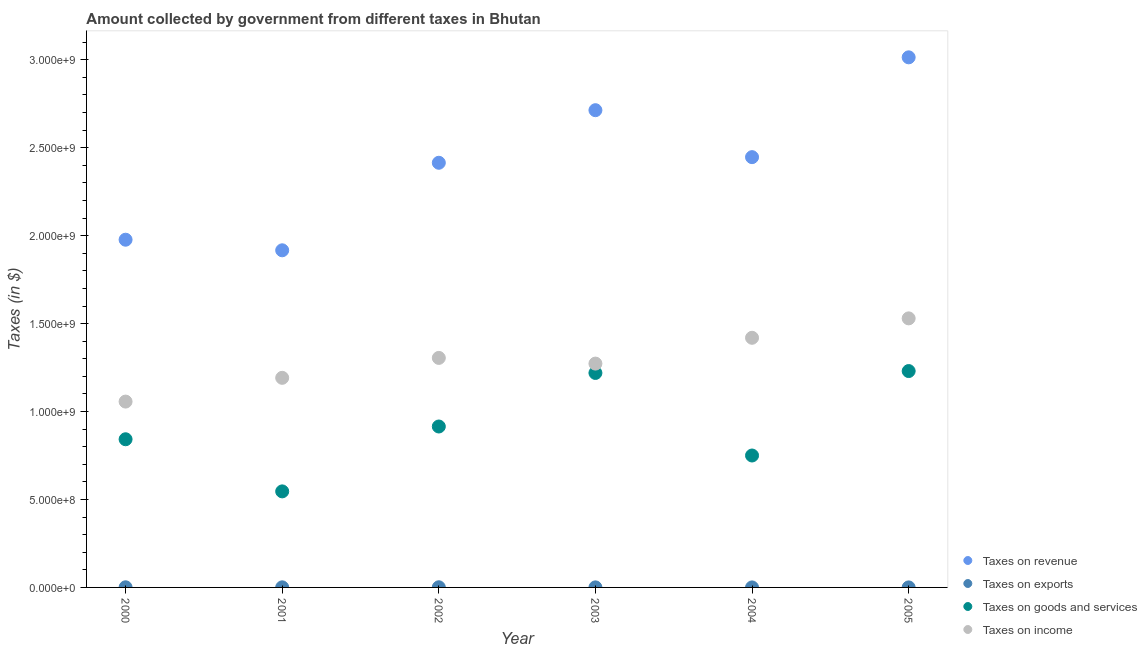Is the number of dotlines equal to the number of legend labels?
Give a very brief answer. Yes. What is the amount collected as tax on income in 2002?
Provide a short and direct response. 1.31e+09. Across all years, what is the maximum amount collected as tax on revenue?
Provide a succinct answer. 3.01e+09. Across all years, what is the minimum amount collected as tax on exports?
Offer a very short reply. 1.20e+04. In which year was the amount collected as tax on exports maximum?
Keep it short and to the point. 2002. What is the total amount collected as tax on income in the graph?
Ensure brevity in your answer.  7.78e+09. What is the difference between the amount collected as tax on exports in 2003 and that in 2005?
Your answer should be very brief. 2.35e+05. What is the difference between the amount collected as tax on exports in 2000 and the amount collected as tax on goods in 2004?
Provide a short and direct response. -7.49e+08. What is the average amount collected as tax on goods per year?
Your response must be concise. 9.17e+08. In the year 2000, what is the difference between the amount collected as tax on exports and amount collected as tax on goods?
Your answer should be compact. -8.42e+08. What is the ratio of the amount collected as tax on exports in 2001 to that in 2002?
Provide a succinct answer. 0.56. Is the difference between the amount collected as tax on revenue in 2001 and 2004 greater than the difference between the amount collected as tax on exports in 2001 and 2004?
Provide a short and direct response. No. What is the difference between the highest and the second highest amount collected as tax on revenue?
Offer a terse response. 3.01e+08. What is the difference between the highest and the lowest amount collected as tax on revenue?
Offer a terse response. 1.10e+09. Does the amount collected as tax on income monotonically increase over the years?
Your response must be concise. No. Is the amount collected as tax on revenue strictly greater than the amount collected as tax on goods over the years?
Keep it short and to the point. Yes. How many dotlines are there?
Give a very brief answer. 4. What is the difference between two consecutive major ticks on the Y-axis?
Provide a short and direct response. 5.00e+08. How many legend labels are there?
Give a very brief answer. 4. How are the legend labels stacked?
Offer a terse response. Vertical. What is the title of the graph?
Your answer should be very brief. Amount collected by government from different taxes in Bhutan. Does "International Development Association" appear as one of the legend labels in the graph?
Your answer should be compact. No. What is the label or title of the X-axis?
Your answer should be very brief. Year. What is the label or title of the Y-axis?
Ensure brevity in your answer.  Taxes (in $). What is the Taxes (in $) of Taxes on revenue in 2000?
Provide a succinct answer. 1.98e+09. What is the Taxes (in $) of Taxes on exports in 2000?
Offer a very short reply. 7.63e+05. What is the Taxes (in $) in Taxes on goods and services in 2000?
Your response must be concise. 8.42e+08. What is the Taxes (in $) in Taxes on income in 2000?
Make the answer very short. 1.06e+09. What is the Taxes (in $) in Taxes on revenue in 2001?
Your answer should be very brief. 1.92e+09. What is the Taxes (in $) of Taxes on exports in 2001?
Offer a very short reply. 4.91e+05. What is the Taxes (in $) in Taxes on goods and services in 2001?
Offer a terse response. 5.46e+08. What is the Taxes (in $) in Taxes on income in 2001?
Make the answer very short. 1.19e+09. What is the Taxes (in $) in Taxes on revenue in 2002?
Your answer should be very brief. 2.41e+09. What is the Taxes (in $) of Taxes on exports in 2002?
Offer a terse response. 8.70e+05. What is the Taxes (in $) of Taxes on goods and services in 2002?
Provide a succinct answer. 9.15e+08. What is the Taxes (in $) of Taxes on income in 2002?
Ensure brevity in your answer.  1.31e+09. What is the Taxes (in $) of Taxes on revenue in 2003?
Give a very brief answer. 2.71e+09. What is the Taxes (in $) in Taxes on exports in 2003?
Ensure brevity in your answer.  3.39e+05. What is the Taxes (in $) in Taxes on goods and services in 2003?
Offer a terse response. 1.22e+09. What is the Taxes (in $) in Taxes on income in 2003?
Your answer should be very brief. 1.27e+09. What is the Taxes (in $) in Taxes on revenue in 2004?
Keep it short and to the point. 2.45e+09. What is the Taxes (in $) in Taxes on exports in 2004?
Your response must be concise. 1.20e+04. What is the Taxes (in $) of Taxes on goods and services in 2004?
Give a very brief answer. 7.50e+08. What is the Taxes (in $) of Taxes on income in 2004?
Make the answer very short. 1.42e+09. What is the Taxes (in $) in Taxes on revenue in 2005?
Keep it short and to the point. 3.01e+09. What is the Taxes (in $) in Taxes on exports in 2005?
Ensure brevity in your answer.  1.04e+05. What is the Taxes (in $) of Taxes on goods and services in 2005?
Provide a short and direct response. 1.23e+09. What is the Taxes (in $) of Taxes on income in 2005?
Provide a short and direct response. 1.53e+09. Across all years, what is the maximum Taxes (in $) of Taxes on revenue?
Offer a terse response. 3.01e+09. Across all years, what is the maximum Taxes (in $) of Taxes on exports?
Provide a short and direct response. 8.70e+05. Across all years, what is the maximum Taxes (in $) in Taxes on goods and services?
Keep it short and to the point. 1.23e+09. Across all years, what is the maximum Taxes (in $) in Taxes on income?
Offer a very short reply. 1.53e+09. Across all years, what is the minimum Taxes (in $) of Taxes on revenue?
Make the answer very short. 1.92e+09. Across all years, what is the minimum Taxes (in $) of Taxes on exports?
Offer a terse response. 1.20e+04. Across all years, what is the minimum Taxes (in $) of Taxes on goods and services?
Provide a short and direct response. 5.46e+08. Across all years, what is the minimum Taxes (in $) in Taxes on income?
Provide a succinct answer. 1.06e+09. What is the total Taxes (in $) in Taxes on revenue in the graph?
Offer a very short reply. 1.45e+1. What is the total Taxes (in $) in Taxes on exports in the graph?
Your answer should be compact. 2.58e+06. What is the total Taxes (in $) of Taxes on goods and services in the graph?
Offer a terse response. 5.50e+09. What is the total Taxes (in $) of Taxes on income in the graph?
Ensure brevity in your answer.  7.78e+09. What is the difference between the Taxes (in $) in Taxes on revenue in 2000 and that in 2001?
Give a very brief answer. 6.02e+07. What is the difference between the Taxes (in $) in Taxes on exports in 2000 and that in 2001?
Your answer should be compact. 2.72e+05. What is the difference between the Taxes (in $) of Taxes on goods and services in 2000 and that in 2001?
Your answer should be compact. 2.96e+08. What is the difference between the Taxes (in $) in Taxes on income in 2000 and that in 2001?
Keep it short and to the point. -1.35e+08. What is the difference between the Taxes (in $) in Taxes on revenue in 2000 and that in 2002?
Give a very brief answer. -4.37e+08. What is the difference between the Taxes (in $) of Taxes on exports in 2000 and that in 2002?
Provide a short and direct response. -1.07e+05. What is the difference between the Taxes (in $) in Taxes on goods and services in 2000 and that in 2002?
Keep it short and to the point. -7.25e+07. What is the difference between the Taxes (in $) in Taxes on income in 2000 and that in 2002?
Your answer should be very brief. -2.48e+08. What is the difference between the Taxes (in $) of Taxes on revenue in 2000 and that in 2003?
Your answer should be very brief. -7.36e+08. What is the difference between the Taxes (in $) in Taxes on exports in 2000 and that in 2003?
Offer a very short reply. 4.24e+05. What is the difference between the Taxes (in $) in Taxes on goods and services in 2000 and that in 2003?
Keep it short and to the point. -3.77e+08. What is the difference between the Taxes (in $) in Taxes on income in 2000 and that in 2003?
Ensure brevity in your answer.  -2.16e+08. What is the difference between the Taxes (in $) in Taxes on revenue in 2000 and that in 2004?
Offer a terse response. -4.69e+08. What is the difference between the Taxes (in $) of Taxes on exports in 2000 and that in 2004?
Offer a terse response. 7.51e+05. What is the difference between the Taxes (in $) in Taxes on goods and services in 2000 and that in 2004?
Provide a short and direct response. 9.24e+07. What is the difference between the Taxes (in $) of Taxes on income in 2000 and that in 2004?
Offer a terse response. -3.63e+08. What is the difference between the Taxes (in $) in Taxes on revenue in 2000 and that in 2005?
Offer a terse response. -1.04e+09. What is the difference between the Taxes (in $) of Taxes on exports in 2000 and that in 2005?
Offer a terse response. 6.59e+05. What is the difference between the Taxes (in $) of Taxes on goods and services in 2000 and that in 2005?
Give a very brief answer. -3.88e+08. What is the difference between the Taxes (in $) in Taxes on income in 2000 and that in 2005?
Ensure brevity in your answer.  -4.73e+08. What is the difference between the Taxes (in $) in Taxes on revenue in 2001 and that in 2002?
Ensure brevity in your answer.  -4.98e+08. What is the difference between the Taxes (in $) in Taxes on exports in 2001 and that in 2002?
Keep it short and to the point. -3.79e+05. What is the difference between the Taxes (in $) in Taxes on goods and services in 2001 and that in 2002?
Provide a succinct answer. -3.69e+08. What is the difference between the Taxes (in $) of Taxes on income in 2001 and that in 2002?
Ensure brevity in your answer.  -1.13e+08. What is the difference between the Taxes (in $) in Taxes on revenue in 2001 and that in 2003?
Make the answer very short. -7.97e+08. What is the difference between the Taxes (in $) of Taxes on exports in 2001 and that in 2003?
Provide a succinct answer. 1.52e+05. What is the difference between the Taxes (in $) in Taxes on goods and services in 2001 and that in 2003?
Keep it short and to the point. -6.73e+08. What is the difference between the Taxes (in $) in Taxes on income in 2001 and that in 2003?
Keep it short and to the point. -8.09e+07. What is the difference between the Taxes (in $) in Taxes on revenue in 2001 and that in 2004?
Provide a succinct answer. -5.30e+08. What is the difference between the Taxes (in $) of Taxes on exports in 2001 and that in 2004?
Your answer should be compact. 4.79e+05. What is the difference between the Taxes (in $) in Taxes on goods and services in 2001 and that in 2004?
Offer a terse response. -2.04e+08. What is the difference between the Taxes (in $) in Taxes on income in 2001 and that in 2004?
Provide a succinct answer. -2.28e+08. What is the difference between the Taxes (in $) in Taxes on revenue in 2001 and that in 2005?
Give a very brief answer. -1.10e+09. What is the difference between the Taxes (in $) of Taxes on exports in 2001 and that in 2005?
Ensure brevity in your answer.  3.87e+05. What is the difference between the Taxes (in $) in Taxes on goods and services in 2001 and that in 2005?
Provide a succinct answer. -6.84e+08. What is the difference between the Taxes (in $) of Taxes on income in 2001 and that in 2005?
Offer a very short reply. -3.38e+08. What is the difference between the Taxes (in $) of Taxes on revenue in 2002 and that in 2003?
Give a very brief answer. -2.99e+08. What is the difference between the Taxes (in $) of Taxes on exports in 2002 and that in 2003?
Offer a very short reply. 5.31e+05. What is the difference between the Taxes (in $) in Taxes on goods and services in 2002 and that in 2003?
Your response must be concise. -3.04e+08. What is the difference between the Taxes (in $) in Taxes on income in 2002 and that in 2003?
Your response must be concise. 3.24e+07. What is the difference between the Taxes (in $) in Taxes on revenue in 2002 and that in 2004?
Give a very brief answer. -3.20e+07. What is the difference between the Taxes (in $) in Taxes on exports in 2002 and that in 2004?
Provide a succinct answer. 8.58e+05. What is the difference between the Taxes (in $) in Taxes on goods and services in 2002 and that in 2004?
Your response must be concise. 1.65e+08. What is the difference between the Taxes (in $) of Taxes on income in 2002 and that in 2004?
Give a very brief answer. -1.14e+08. What is the difference between the Taxes (in $) in Taxes on revenue in 2002 and that in 2005?
Ensure brevity in your answer.  -6.00e+08. What is the difference between the Taxes (in $) of Taxes on exports in 2002 and that in 2005?
Ensure brevity in your answer.  7.66e+05. What is the difference between the Taxes (in $) in Taxes on goods and services in 2002 and that in 2005?
Your response must be concise. -3.15e+08. What is the difference between the Taxes (in $) of Taxes on income in 2002 and that in 2005?
Your answer should be very brief. -2.25e+08. What is the difference between the Taxes (in $) in Taxes on revenue in 2003 and that in 2004?
Your response must be concise. 2.67e+08. What is the difference between the Taxes (in $) in Taxes on exports in 2003 and that in 2004?
Give a very brief answer. 3.27e+05. What is the difference between the Taxes (in $) of Taxes on goods and services in 2003 and that in 2004?
Offer a terse response. 4.69e+08. What is the difference between the Taxes (in $) in Taxes on income in 2003 and that in 2004?
Offer a very short reply. -1.47e+08. What is the difference between the Taxes (in $) in Taxes on revenue in 2003 and that in 2005?
Provide a succinct answer. -3.01e+08. What is the difference between the Taxes (in $) of Taxes on exports in 2003 and that in 2005?
Ensure brevity in your answer.  2.35e+05. What is the difference between the Taxes (in $) of Taxes on goods and services in 2003 and that in 2005?
Your response must be concise. -1.08e+07. What is the difference between the Taxes (in $) of Taxes on income in 2003 and that in 2005?
Offer a terse response. -2.57e+08. What is the difference between the Taxes (in $) in Taxes on revenue in 2004 and that in 2005?
Offer a very short reply. -5.68e+08. What is the difference between the Taxes (in $) of Taxes on exports in 2004 and that in 2005?
Ensure brevity in your answer.  -9.20e+04. What is the difference between the Taxes (in $) in Taxes on goods and services in 2004 and that in 2005?
Your answer should be compact. -4.80e+08. What is the difference between the Taxes (in $) in Taxes on income in 2004 and that in 2005?
Your answer should be very brief. -1.10e+08. What is the difference between the Taxes (in $) in Taxes on revenue in 2000 and the Taxes (in $) in Taxes on exports in 2001?
Provide a short and direct response. 1.98e+09. What is the difference between the Taxes (in $) of Taxes on revenue in 2000 and the Taxes (in $) of Taxes on goods and services in 2001?
Your response must be concise. 1.43e+09. What is the difference between the Taxes (in $) in Taxes on revenue in 2000 and the Taxes (in $) in Taxes on income in 2001?
Ensure brevity in your answer.  7.85e+08. What is the difference between the Taxes (in $) in Taxes on exports in 2000 and the Taxes (in $) in Taxes on goods and services in 2001?
Make the answer very short. -5.45e+08. What is the difference between the Taxes (in $) in Taxes on exports in 2000 and the Taxes (in $) in Taxes on income in 2001?
Ensure brevity in your answer.  -1.19e+09. What is the difference between the Taxes (in $) in Taxes on goods and services in 2000 and the Taxes (in $) in Taxes on income in 2001?
Offer a very short reply. -3.49e+08. What is the difference between the Taxes (in $) of Taxes on revenue in 2000 and the Taxes (in $) of Taxes on exports in 2002?
Keep it short and to the point. 1.98e+09. What is the difference between the Taxes (in $) in Taxes on revenue in 2000 and the Taxes (in $) in Taxes on goods and services in 2002?
Offer a terse response. 1.06e+09. What is the difference between the Taxes (in $) of Taxes on revenue in 2000 and the Taxes (in $) of Taxes on income in 2002?
Offer a very short reply. 6.72e+08. What is the difference between the Taxes (in $) of Taxes on exports in 2000 and the Taxes (in $) of Taxes on goods and services in 2002?
Offer a very short reply. -9.14e+08. What is the difference between the Taxes (in $) in Taxes on exports in 2000 and the Taxes (in $) in Taxes on income in 2002?
Give a very brief answer. -1.30e+09. What is the difference between the Taxes (in $) of Taxes on goods and services in 2000 and the Taxes (in $) of Taxes on income in 2002?
Your answer should be very brief. -4.63e+08. What is the difference between the Taxes (in $) in Taxes on revenue in 2000 and the Taxes (in $) in Taxes on exports in 2003?
Provide a short and direct response. 1.98e+09. What is the difference between the Taxes (in $) of Taxes on revenue in 2000 and the Taxes (in $) of Taxes on goods and services in 2003?
Your answer should be very brief. 7.58e+08. What is the difference between the Taxes (in $) of Taxes on revenue in 2000 and the Taxes (in $) of Taxes on income in 2003?
Give a very brief answer. 7.04e+08. What is the difference between the Taxes (in $) in Taxes on exports in 2000 and the Taxes (in $) in Taxes on goods and services in 2003?
Your answer should be very brief. -1.22e+09. What is the difference between the Taxes (in $) of Taxes on exports in 2000 and the Taxes (in $) of Taxes on income in 2003?
Offer a very short reply. -1.27e+09. What is the difference between the Taxes (in $) of Taxes on goods and services in 2000 and the Taxes (in $) of Taxes on income in 2003?
Your answer should be very brief. -4.30e+08. What is the difference between the Taxes (in $) of Taxes on revenue in 2000 and the Taxes (in $) of Taxes on exports in 2004?
Give a very brief answer. 1.98e+09. What is the difference between the Taxes (in $) of Taxes on revenue in 2000 and the Taxes (in $) of Taxes on goods and services in 2004?
Your answer should be compact. 1.23e+09. What is the difference between the Taxes (in $) in Taxes on revenue in 2000 and the Taxes (in $) in Taxes on income in 2004?
Provide a short and direct response. 5.58e+08. What is the difference between the Taxes (in $) in Taxes on exports in 2000 and the Taxes (in $) in Taxes on goods and services in 2004?
Give a very brief answer. -7.49e+08. What is the difference between the Taxes (in $) of Taxes on exports in 2000 and the Taxes (in $) of Taxes on income in 2004?
Make the answer very short. -1.42e+09. What is the difference between the Taxes (in $) in Taxes on goods and services in 2000 and the Taxes (in $) in Taxes on income in 2004?
Your response must be concise. -5.77e+08. What is the difference between the Taxes (in $) in Taxes on revenue in 2000 and the Taxes (in $) in Taxes on exports in 2005?
Provide a short and direct response. 1.98e+09. What is the difference between the Taxes (in $) of Taxes on revenue in 2000 and the Taxes (in $) of Taxes on goods and services in 2005?
Provide a short and direct response. 7.47e+08. What is the difference between the Taxes (in $) in Taxes on revenue in 2000 and the Taxes (in $) in Taxes on income in 2005?
Provide a succinct answer. 4.47e+08. What is the difference between the Taxes (in $) of Taxes on exports in 2000 and the Taxes (in $) of Taxes on goods and services in 2005?
Provide a short and direct response. -1.23e+09. What is the difference between the Taxes (in $) of Taxes on exports in 2000 and the Taxes (in $) of Taxes on income in 2005?
Offer a very short reply. -1.53e+09. What is the difference between the Taxes (in $) in Taxes on goods and services in 2000 and the Taxes (in $) in Taxes on income in 2005?
Your answer should be compact. -6.87e+08. What is the difference between the Taxes (in $) in Taxes on revenue in 2001 and the Taxes (in $) in Taxes on exports in 2002?
Your answer should be compact. 1.92e+09. What is the difference between the Taxes (in $) in Taxes on revenue in 2001 and the Taxes (in $) in Taxes on goods and services in 2002?
Give a very brief answer. 1.00e+09. What is the difference between the Taxes (in $) of Taxes on revenue in 2001 and the Taxes (in $) of Taxes on income in 2002?
Provide a short and direct response. 6.12e+08. What is the difference between the Taxes (in $) in Taxes on exports in 2001 and the Taxes (in $) in Taxes on goods and services in 2002?
Offer a terse response. -9.15e+08. What is the difference between the Taxes (in $) in Taxes on exports in 2001 and the Taxes (in $) in Taxes on income in 2002?
Ensure brevity in your answer.  -1.30e+09. What is the difference between the Taxes (in $) in Taxes on goods and services in 2001 and the Taxes (in $) in Taxes on income in 2002?
Your response must be concise. -7.59e+08. What is the difference between the Taxes (in $) in Taxes on revenue in 2001 and the Taxes (in $) in Taxes on exports in 2003?
Your answer should be compact. 1.92e+09. What is the difference between the Taxes (in $) in Taxes on revenue in 2001 and the Taxes (in $) in Taxes on goods and services in 2003?
Offer a terse response. 6.97e+08. What is the difference between the Taxes (in $) in Taxes on revenue in 2001 and the Taxes (in $) in Taxes on income in 2003?
Give a very brief answer. 6.44e+08. What is the difference between the Taxes (in $) of Taxes on exports in 2001 and the Taxes (in $) of Taxes on goods and services in 2003?
Make the answer very short. -1.22e+09. What is the difference between the Taxes (in $) in Taxes on exports in 2001 and the Taxes (in $) in Taxes on income in 2003?
Provide a succinct answer. -1.27e+09. What is the difference between the Taxes (in $) of Taxes on goods and services in 2001 and the Taxes (in $) of Taxes on income in 2003?
Make the answer very short. -7.27e+08. What is the difference between the Taxes (in $) in Taxes on revenue in 2001 and the Taxes (in $) in Taxes on exports in 2004?
Your answer should be very brief. 1.92e+09. What is the difference between the Taxes (in $) of Taxes on revenue in 2001 and the Taxes (in $) of Taxes on goods and services in 2004?
Ensure brevity in your answer.  1.17e+09. What is the difference between the Taxes (in $) of Taxes on revenue in 2001 and the Taxes (in $) of Taxes on income in 2004?
Offer a terse response. 4.97e+08. What is the difference between the Taxes (in $) of Taxes on exports in 2001 and the Taxes (in $) of Taxes on goods and services in 2004?
Keep it short and to the point. -7.50e+08. What is the difference between the Taxes (in $) of Taxes on exports in 2001 and the Taxes (in $) of Taxes on income in 2004?
Your answer should be compact. -1.42e+09. What is the difference between the Taxes (in $) of Taxes on goods and services in 2001 and the Taxes (in $) of Taxes on income in 2004?
Ensure brevity in your answer.  -8.73e+08. What is the difference between the Taxes (in $) in Taxes on revenue in 2001 and the Taxes (in $) in Taxes on exports in 2005?
Provide a short and direct response. 1.92e+09. What is the difference between the Taxes (in $) in Taxes on revenue in 2001 and the Taxes (in $) in Taxes on goods and services in 2005?
Provide a short and direct response. 6.87e+08. What is the difference between the Taxes (in $) in Taxes on revenue in 2001 and the Taxes (in $) in Taxes on income in 2005?
Your answer should be compact. 3.87e+08. What is the difference between the Taxes (in $) of Taxes on exports in 2001 and the Taxes (in $) of Taxes on goods and services in 2005?
Your answer should be compact. -1.23e+09. What is the difference between the Taxes (in $) in Taxes on exports in 2001 and the Taxes (in $) in Taxes on income in 2005?
Provide a short and direct response. -1.53e+09. What is the difference between the Taxes (in $) in Taxes on goods and services in 2001 and the Taxes (in $) in Taxes on income in 2005?
Keep it short and to the point. -9.84e+08. What is the difference between the Taxes (in $) in Taxes on revenue in 2002 and the Taxes (in $) in Taxes on exports in 2003?
Your answer should be very brief. 2.41e+09. What is the difference between the Taxes (in $) in Taxes on revenue in 2002 and the Taxes (in $) in Taxes on goods and services in 2003?
Keep it short and to the point. 1.20e+09. What is the difference between the Taxes (in $) in Taxes on revenue in 2002 and the Taxes (in $) in Taxes on income in 2003?
Give a very brief answer. 1.14e+09. What is the difference between the Taxes (in $) of Taxes on exports in 2002 and the Taxes (in $) of Taxes on goods and services in 2003?
Keep it short and to the point. -1.22e+09. What is the difference between the Taxes (in $) in Taxes on exports in 2002 and the Taxes (in $) in Taxes on income in 2003?
Provide a short and direct response. -1.27e+09. What is the difference between the Taxes (in $) in Taxes on goods and services in 2002 and the Taxes (in $) in Taxes on income in 2003?
Ensure brevity in your answer.  -3.58e+08. What is the difference between the Taxes (in $) in Taxes on revenue in 2002 and the Taxes (in $) in Taxes on exports in 2004?
Offer a terse response. 2.41e+09. What is the difference between the Taxes (in $) of Taxes on revenue in 2002 and the Taxes (in $) of Taxes on goods and services in 2004?
Your answer should be very brief. 1.66e+09. What is the difference between the Taxes (in $) in Taxes on revenue in 2002 and the Taxes (in $) in Taxes on income in 2004?
Your response must be concise. 9.95e+08. What is the difference between the Taxes (in $) in Taxes on exports in 2002 and the Taxes (in $) in Taxes on goods and services in 2004?
Keep it short and to the point. -7.49e+08. What is the difference between the Taxes (in $) of Taxes on exports in 2002 and the Taxes (in $) of Taxes on income in 2004?
Your answer should be very brief. -1.42e+09. What is the difference between the Taxes (in $) in Taxes on goods and services in 2002 and the Taxes (in $) in Taxes on income in 2004?
Offer a very short reply. -5.04e+08. What is the difference between the Taxes (in $) in Taxes on revenue in 2002 and the Taxes (in $) in Taxes on exports in 2005?
Make the answer very short. 2.41e+09. What is the difference between the Taxes (in $) of Taxes on revenue in 2002 and the Taxes (in $) of Taxes on goods and services in 2005?
Your response must be concise. 1.18e+09. What is the difference between the Taxes (in $) of Taxes on revenue in 2002 and the Taxes (in $) of Taxes on income in 2005?
Give a very brief answer. 8.85e+08. What is the difference between the Taxes (in $) in Taxes on exports in 2002 and the Taxes (in $) in Taxes on goods and services in 2005?
Keep it short and to the point. -1.23e+09. What is the difference between the Taxes (in $) in Taxes on exports in 2002 and the Taxes (in $) in Taxes on income in 2005?
Give a very brief answer. -1.53e+09. What is the difference between the Taxes (in $) of Taxes on goods and services in 2002 and the Taxes (in $) of Taxes on income in 2005?
Give a very brief answer. -6.15e+08. What is the difference between the Taxes (in $) in Taxes on revenue in 2003 and the Taxes (in $) in Taxes on exports in 2004?
Provide a succinct answer. 2.71e+09. What is the difference between the Taxes (in $) in Taxes on revenue in 2003 and the Taxes (in $) in Taxes on goods and services in 2004?
Keep it short and to the point. 1.96e+09. What is the difference between the Taxes (in $) in Taxes on revenue in 2003 and the Taxes (in $) in Taxes on income in 2004?
Provide a short and direct response. 1.29e+09. What is the difference between the Taxes (in $) in Taxes on exports in 2003 and the Taxes (in $) in Taxes on goods and services in 2004?
Provide a succinct answer. -7.50e+08. What is the difference between the Taxes (in $) in Taxes on exports in 2003 and the Taxes (in $) in Taxes on income in 2004?
Offer a very short reply. -1.42e+09. What is the difference between the Taxes (in $) of Taxes on goods and services in 2003 and the Taxes (in $) of Taxes on income in 2004?
Your answer should be compact. -2.00e+08. What is the difference between the Taxes (in $) in Taxes on revenue in 2003 and the Taxes (in $) in Taxes on exports in 2005?
Offer a very short reply. 2.71e+09. What is the difference between the Taxes (in $) in Taxes on revenue in 2003 and the Taxes (in $) in Taxes on goods and services in 2005?
Offer a very short reply. 1.48e+09. What is the difference between the Taxes (in $) of Taxes on revenue in 2003 and the Taxes (in $) of Taxes on income in 2005?
Ensure brevity in your answer.  1.18e+09. What is the difference between the Taxes (in $) of Taxes on exports in 2003 and the Taxes (in $) of Taxes on goods and services in 2005?
Provide a succinct answer. -1.23e+09. What is the difference between the Taxes (in $) of Taxes on exports in 2003 and the Taxes (in $) of Taxes on income in 2005?
Give a very brief answer. -1.53e+09. What is the difference between the Taxes (in $) of Taxes on goods and services in 2003 and the Taxes (in $) of Taxes on income in 2005?
Your answer should be compact. -3.10e+08. What is the difference between the Taxes (in $) in Taxes on revenue in 2004 and the Taxes (in $) in Taxes on exports in 2005?
Offer a terse response. 2.45e+09. What is the difference between the Taxes (in $) of Taxes on revenue in 2004 and the Taxes (in $) of Taxes on goods and services in 2005?
Give a very brief answer. 1.22e+09. What is the difference between the Taxes (in $) in Taxes on revenue in 2004 and the Taxes (in $) in Taxes on income in 2005?
Your answer should be compact. 9.17e+08. What is the difference between the Taxes (in $) in Taxes on exports in 2004 and the Taxes (in $) in Taxes on goods and services in 2005?
Your answer should be compact. -1.23e+09. What is the difference between the Taxes (in $) in Taxes on exports in 2004 and the Taxes (in $) in Taxes on income in 2005?
Your response must be concise. -1.53e+09. What is the difference between the Taxes (in $) in Taxes on goods and services in 2004 and the Taxes (in $) in Taxes on income in 2005?
Make the answer very short. -7.80e+08. What is the average Taxes (in $) of Taxes on revenue per year?
Provide a short and direct response. 2.41e+09. What is the average Taxes (in $) of Taxes on exports per year?
Provide a succinct answer. 4.30e+05. What is the average Taxes (in $) of Taxes on goods and services per year?
Provide a short and direct response. 9.17e+08. What is the average Taxes (in $) in Taxes on income per year?
Provide a short and direct response. 1.30e+09. In the year 2000, what is the difference between the Taxes (in $) of Taxes on revenue and Taxes (in $) of Taxes on exports?
Your response must be concise. 1.98e+09. In the year 2000, what is the difference between the Taxes (in $) of Taxes on revenue and Taxes (in $) of Taxes on goods and services?
Make the answer very short. 1.13e+09. In the year 2000, what is the difference between the Taxes (in $) of Taxes on revenue and Taxes (in $) of Taxes on income?
Your answer should be compact. 9.20e+08. In the year 2000, what is the difference between the Taxes (in $) in Taxes on exports and Taxes (in $) in Taxes on goods and services?
Provide a succinct answer. -8.42e+08. In the year 2000, what is the difference between the Taxes (in $) of Taxes on exports and Taxes (in $) of Taxes on income?
Your answer should be compact. -1.06e+09. In the year 2000, what is the difference between the Taxes (in $) in Taxes on goods and services and Taxes (in $) in Taxes on income?
Give a very brief answer. -2.14e+08. In the year 2001, what is the difference between the Taxes (in $) in Taxes on revenue and Taxes (in $) in Taxes on exports?
Offer a very short reply. 1.92e+09. In the year 2001, what is the difference between the Taxes (in $) in Taxes on revenue and Taxes (in $) in Taxes on goods and services?
Your answer should be very brief. 1.37e+09. In the year 2001, what is the difference between the Taxes (in $) of Taxes on revenue and Taxes (in $) of Taxes on income?
Give a very brief answer. 7.25e+08. In the year 2001, what is the difference between the Taxes (in $) in Taxes on exports and Taxes (in $) in Taxes on goods and services?
Keep it short and to the point. -5.46e+08. In the year 2001, what is the difference between the Taxes (in $) of Taxes on exports and Taxes (in $) of Taxes on income?
Provide a short and direct response. -1.19e+09. In the year 2001, what is the difference between the Taxes (in $) in Taxes on goods and services and Taxes (in $) in Taxes on income?
Offer a terse response. -6.46e+08. In the year 2002, what is the difference between the Taxes (in $) in Taxes on revenue and Taxes (in $) in Taxes on exports?
Offer a terse response. 2.41e+09. In the year 2002, what is the difference between the Taxes (in $) in Taxes on revenue and Taxes (in $) in Taxes on goods and services?
Give a very brief answer. 1.50e+09. In the year 2002, what is the difference between the Taxes (in $) in Taxes on revenue and Taxes (in $) in Taxes on income?
Offer a very short reply. 1.11e+09. In the year 2002, what is the difference between the Taxes (in $) of Taxes on exports and Taxes (in $) of Taxes on goods and services?
Ensure brevity in your answer.  -9.14e+08. In the year 2002, what is the difference between the Taxes (in $) of Taxes on exports and Taxes (in $) of Taxes on income?
Your response must be concise. -1.30e+09. In the year 2002, what is the difference between the Taxes (in $) of Taxes on goods and services and Taxes (in $) of Taxes on income?
Ensure brevity in your answer.  -3.90e+08. In the year 2003, what is the difference between the Taxes (in $) in Taxes on revenue and Taxes (in $) in Taxes on exports?
Give a very brief answer. 2.71e+09. In the year 2003, what is the difference between the Taxes (in $) in Taxes on revenue and Taxes (in $) in Taxes on goods and services?
Keep it short and to the point. 1.49e+09. In the year 2003, what is the difference between the Taxes (in $) in Taxes on revenue and Taxes (in $) in Taxes on income?
Provide a short and direct response. 1.44e+09. In the year 2003, what is the difference between the Taxes (in $) in Taxes on exports and Taxes (in $) in Taxes on goods and services?
Give a very brief answer. -1.22e+09. In the year 2003, what is the difference between the Taxes (in $) of Taxes on exports and Taxes (in $) of Taxes on income?
Offer a very short reply. -1.27e+09. In the year 2003, what is the difference between the Taxes (in $) in Taxes on goods and services and Taxes (in $) in Taxes on income?
Ensure brevity in your answer.  -5.32e+07. In the year 2004, what is the difference between the Taxes (in $) of Taxes on revenue and Taxes (in $) of Taxes on exports?
Ensure brevity in your answer.  2.45e+09. In the year 2004, what is the difference between the Taxes (in $) of Taxes on revenue and Taxes (in $) of Taxes on goods and services?
Offer a terse response. 1.70e+09. In the year 2004, what is the difference between the Taxes (in $) in Taxes on revenue and Taxes (in $) in Taxes on income?
Your answer should be very brief. 1.03e+09. In the year 2004, what is the difference between the Taxes (in $) in Taxes on exports and Taxes (in $) in Taxes on goods and services?
Give a very brief answer. -7.50e+08. In the year 2004, what is the difference between the Taxes (in $) in Taxes on exports and Taxes (in $) in Taxes on income?
Ensure brevity in your answer.  -1.42e+09. In the year 2004, what is the difference between the Taxes (in $) of Taxes on goods and services and Taxes (in $) of Taxes on income?
Keep it short and to the point. -6.69e+08. In the year 2005, what is the difference between the Taxes (in $) of Taxes on revenue and Taxes (in $) of Taxes on exports?
Make the answer very short. 3.01e+09. In the year 2005, what is the difference between the Taxes (in $) in Taxes on revenue and Taxes (in $) in Taxes on goods and services?
Make the answer very short. 1.78e+09. In the year 2005, what is the difference between the Taxes (in $) in Taxes on revenue and Taxes (in $) in Taxes on income?
Ensure brevity in your answer.  1.48e+09. In the year 2005, what is the difference between the Taxes (in $) of Taxes on exports and Taxes (in $) of Taxes on goods and services?
Offer a very short reply. -1.23e+09. In the year 2005, what is the difference between the Taxes (in $) in Taxes on exports and Taxes (in $) in Taxes on income?
Make the answer very short. -1.53e+09. In the year 2005, what is the difference between the Taxes (in $) of Taxes on goods and services and Taxes (in $) of Taxes on income?
Your response must be concise. -3.00e+08. What is the ratio of the Taxes (in $) in Taxes on revenue in 2000 to that in 2001?
Keep it short and to the point. 1.03. What is the ratio of the Taxes (in $) of Taxes on exports in 2000 to that in 2001?
Make the answer very short. 1.55. What is the ratio of the Taxes (in $) of Taxes on goods and services in 2000 to that in 2001?
Make the answer very short. 1.54. What is the ratio of the Taxes (in $) in Taxes on income in 2000 to that in 2001?
Offer a very short reply. 0.89. What is the ratio of the Taxes (in $) in Taxes on revenue in 2000 to that in 2002?
Offer a terse response. 0.82. What is the ratio of the Taxes (in $) in Taxes on exports in 2000 to that in 2002?
Give a very brief answer. 0.88. What is the ratio of the Taxes (in $) in Taxes on goods and services in 2000 to that in 2002?
Offer a very short reply. 0.92. What is the ratio of the Taxes (in $) in Taxes on income in 2000 to that in 2002?
Make the answer very short. 0.81. What is the ratio of the Taxes (in $) in Taxes on revenue in 2000 to that in 2003?
Make the answer very short. 0.73. What is the ratio of the Taxes (in $) of Taxes on exports in 2000 to that in 2003?
Keep it short and to the point. 2.25. What is the ratio of the Taxes (in $) of Taxes on goods and services in 2000 to that in 2003?
Offer a terse response. 0.69. What is the ratio of the Taxes (in $) in Taxes on income in 2000 to that in 2003?
Give a very brief answer. 0.83. What is the ratio of the Taxes (in $) in Taxes on revenue in 2000 to that in 2004?
Your answer should be very brief. 0.81. What is the ratio of the Taxes (in $) in Taxes on exports in 2000 to that in 2004?
Keep it short and to the point. 63.58. What is the ratio of the Taxes (in $) in Taxes on goods and services in 2000 to that in 2004?
Ensure brevity in your answer.  1.12. What is the ratio of the Taxes (in $) in Taxes on income in 2000 to that in 2004?
Offer a terse response. 0.74. What is the ratio of the Taxes (in $) in Taxes on revenue in 2000 to that in 2005?
Provide a short and direct response. 0.66. What is the ratio of the Taxes (in $) of Taxes on exports in 2000 to that in 2005?
Offer a very short reply. 7.34. What is the ratio of the Taxes (in $) of Taxes on goods and services in 2000 to that in 2005?
Make the answer very short. 0.68. What is the ratio of the Taxes (in $) of Taxes on income in 2000 to that in 2005?
Keep it short and to the point. 0.69. What is the ratio of the Taxes (in $) of Taxes on revenue in 2001 to that in 2002?
Provide a succinct answer. 0.79. What is the ratio of the Taxes (in $) in Taxes on exports in 2001 to that in 2002?
Offer a very short reply. 0.56. What is the ratio of the Taxes (in $) in Taxes on goods and services in 2001 to that in 2002?
Ensure brevity in your answer.  0.6. What is the ratio of the Taxes (in $) of Taxes on income in 2001 to that in 2002?
Provide a succinct answer. 0.91. What is the ratio of the Taxes (in $) of Taxes on revenue in 2001 to that in 2003?
Ensure brevity in your answer.  0.71. What is the ratio of the Taxes (in $) of Taxes on exports in 2001 to that in 2003?
Make the answer very short. 1.45. What is the ratio of the Taxes (in $) in Taxes on goods and services in 2001 to that in 2003?
Give a very brief answer. 0.45. What is the ratio of the Taxes (in $) in Taxes on income in 2001 to that in 2003?
Offer a very short reply. 0.94. What is the ratio of the Taxes (in $) in Taxes on revenue in 2001 to that in 2004?
Keep it short and to the point. 0.78. What is the ratio of the Taxes (in $) of Taxes on exports in 2001 to that in 2004?
Make the answer very short. 40.92. What is the ratio of the Taxes (in $) in Taxes on goods and services in 2001 to that in 2004?
Your answer should be very brief. 0.73. What is the ratio of the Taxes (in $) of Taxes on income in 2001 to that in 2004?
Provide a succinct answer. 0.84. What is the ratio of the Taxes (in $) of Taxes on revenue in 2001 to that in 2005?
Make the answer very short. 0.64. What is the ratio of the Taxes (in $) of Taxes on exports in 2001 to that in 2005?
Make the answer very short. 4.72. What is the ratio of the Taxes (in $) of Taxes on goods and services in 2001 to that in 2005?
Your response must be concise. 0.44. What is the ratio of the Taxes (in $) of Taxes on income in 2001 to that in 2005?
Keep it short and to the point. 0.78. What is the ratio of the Taxes (in $) in Taxes on revenue in 2002 to that in 2003?
Provide a short and direct response. 0.89. What is the ratio of the Taxes (in $) in Taxes on exports in 2002 to that in 2003?
Offer a terse response. 2.57. What is the ratio of the Taxes (in $) in Taxes on goods and services in 2002 to that in 2003?
Your answer should be compact. 0.75. What is the ratio of the Taxes (in $) in Taxes on income in 2002 to that in 2003?
Your answer should be compact. 1.03. What is the ratio of the Taxes (in $) in Taxes on revenue in 2002 to that in 2004?
Ensure brevity in your answer.  0.99. What is the ratio of the Taxes (in $) in Taxes on exports in 2002 to that in 2004?
Ensure brevity in your answer.  72.5. What is the ratio of the Taxes (in $) of Taxes on goods and services in 2002 to that in 2004?
Ensure brevity in your answer.  1.22. What is the ratio of the Taxes (in $) of Taxes on income in 2002 to that in 2004?
Your answer should be compact. 0.92. What is the ratio of the Taxes (in $) of Taxes on revenue in 2002 to that in 2005?
Your answer should be compact. 0.8. What is the ratio of the Taxes (in $) of Taxes on exports in 2002 to that in 2005?
Keep it short and to the point. 8.37. What is the ratio of the Taxes (in $) in Taxes on goods and services in 2002 to that in 2005?
Provide a short and direct response. 0.74. What is the ratio of the Taxes (in $) of Taxes on income in 2002 to that in 2005?
Your answer should be very brief. 0.85. What is the ratio of the Taxes (in $) of Taxes on revenue in 2003 to that in 2004?
Give a very brief answer. 1.11. What is the ratio of the Taxes (in $) of Taxes on exports in 2003 to that in 2004?
Give a very brief answer. 28.25. What is the ratio of the Taxes (in $) of Taxes on goods and services in 2003 to that in 2004?
Give a very brief answer. 1.63. What is the ratio of the Taxes (in $) in Taxes on income in 2003 to that in 2004?
Give a very brief answer. 0.9. What is the ratio of the Taxes (in $) in Taxes on revenue in 2003 to that in 2005?
Make the answer very short. 0.9. What is the ratio of the Taxes (in $) of Taxes on exports in 2003 to that in 2005?
Provide a succinct answer. 3.26. What is the ratio of the Taxes (in $) of Taxes on income in 2003 to that in 2005?
Keep it short and to the point. 0.83. What is the ratio of the Taxes (in $) of Taxes on revenue in 2004 to that in 2005?
Give a very brief answer. 0.81. What is the ratio of the Taxes (in $) in Taxes on exports in 2004 to that in 2005?
Give a very brief answer. 0.12. What is the ratio of the Taxes (in $) of Taxes on goods and services in 2004 to that in 2005?
Provide a short and direct response. 0.61. What is the ratio of the Taxes (in $) of Taxes on income in 2004 to that in 2005?
Give a very brief answer. 0.93. What is the difference between the highest and the second highest Taxes (in $) of Taxes on revenue?
Keep it short and to the point. 3.01e+08. What is the difference between the highest and the second highest Taxes (in $) of Taxes on exports?
Provide a short and direct response. 1.07e+05. What is the difference between the highest and the second highest Taxes (in $) in Taxes on goods and services?
Make the answer very short. 1.08e+07. What is the difference between the highest and the second highest Taxes (in $) in Taxes on income?
Your response must be concise. 1.10e+08. What is the difference between the highest and the lowest Taxes (in $) of Taxes on revenue?
Your response must be concise. 1.10e+09. What is the difference between the highest and the lowest Taxes (in $) of Taxes on exports?
Keep it short and to the point. 8.58e+05. What is the difference between the highest and the lowest Taxes (in $) of Taxes on goods and services?
Offer a terse response. 6.84e+08. What is the difference between the highest and the lowest Taxes (in $) in Taxes on income?
Your response must be concise. 4.73e+08. 